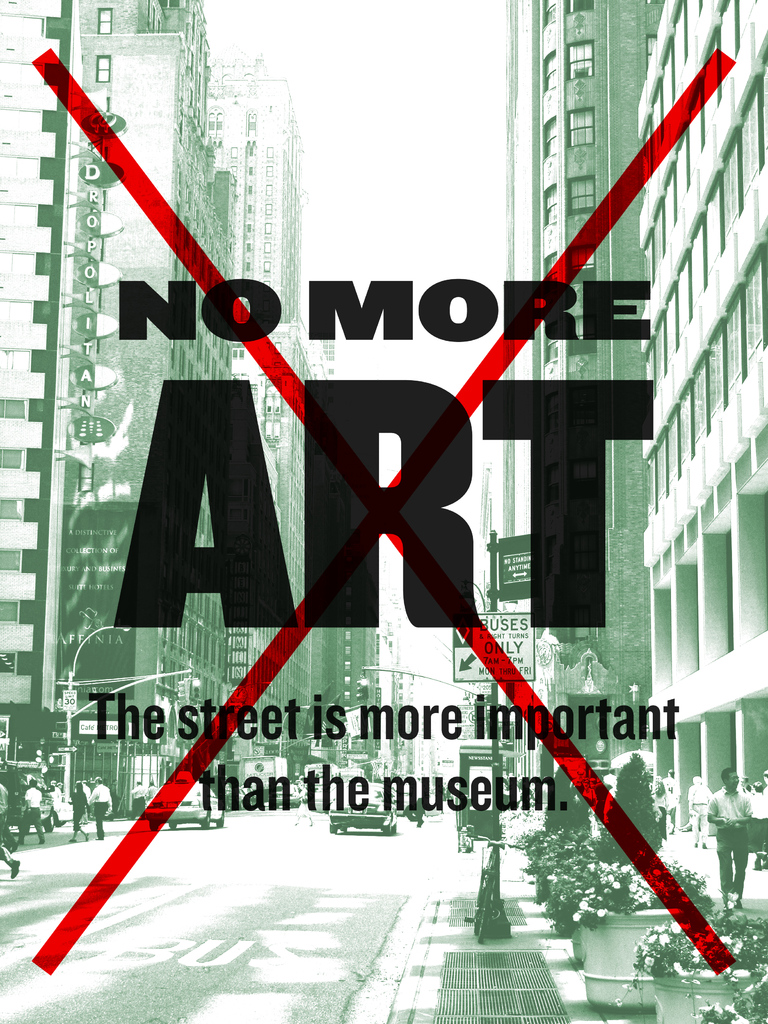What does the red 'X' signify in this image? The red 'X' is a powerful symbol in this context. It signifies rejection and negation. By overlaying this mark across the cityscape, it communicates a clear disapproval of the current state of public spaces or how art is traditionally confined within the walls of museums. The 'X' can be interpreted as a call to rethink and repurpose our urban environment to better serve social and artistic exchanges. 